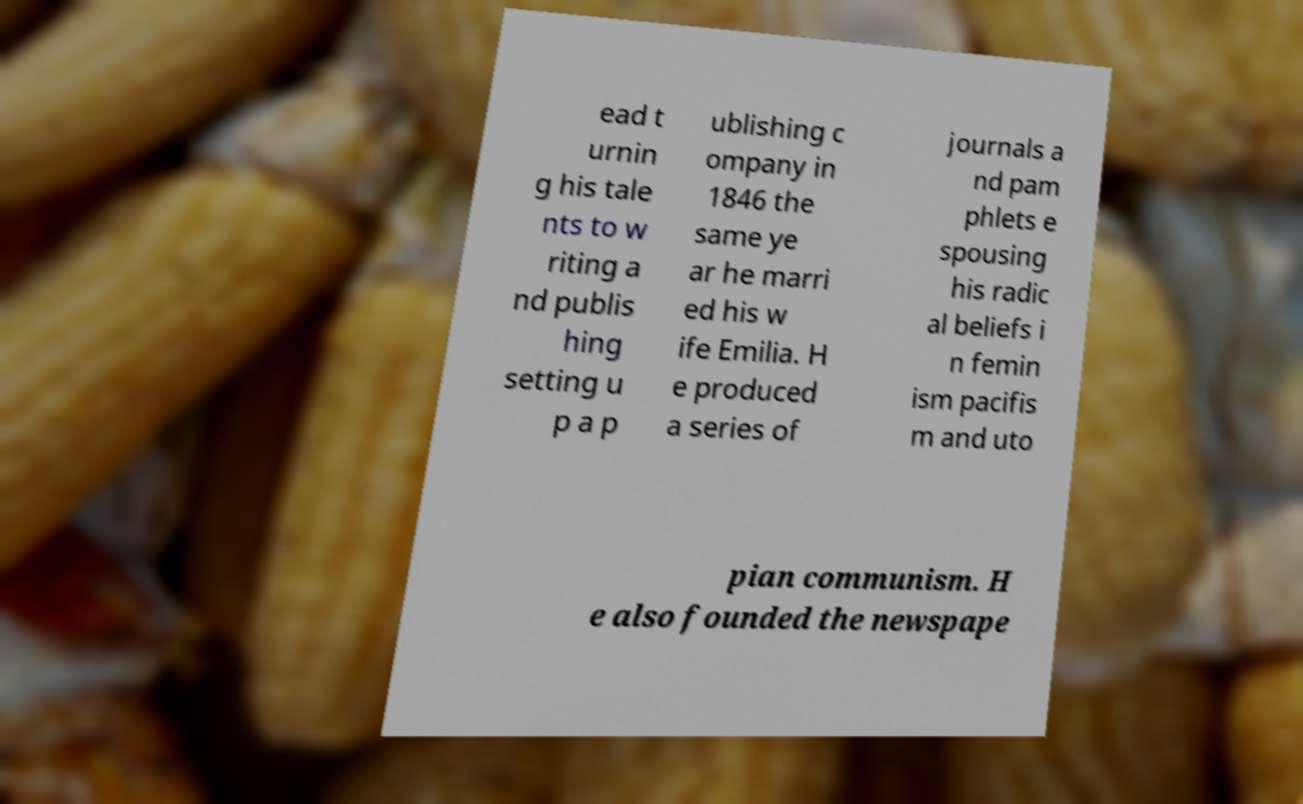Could you assist in decoding the text presented in this image and type it out clearly? ead t urnin g his tale nts to w riting a nd publis hing setting u p a p ublishing c ompany in 1846 the same ye ar he marri ed his w ife Emilia. H e produced a series of journals a nd pam phlets e spousing his radic al beliefs i n femin ism pacifis m and uto pian communism. H e also founded the newspape 